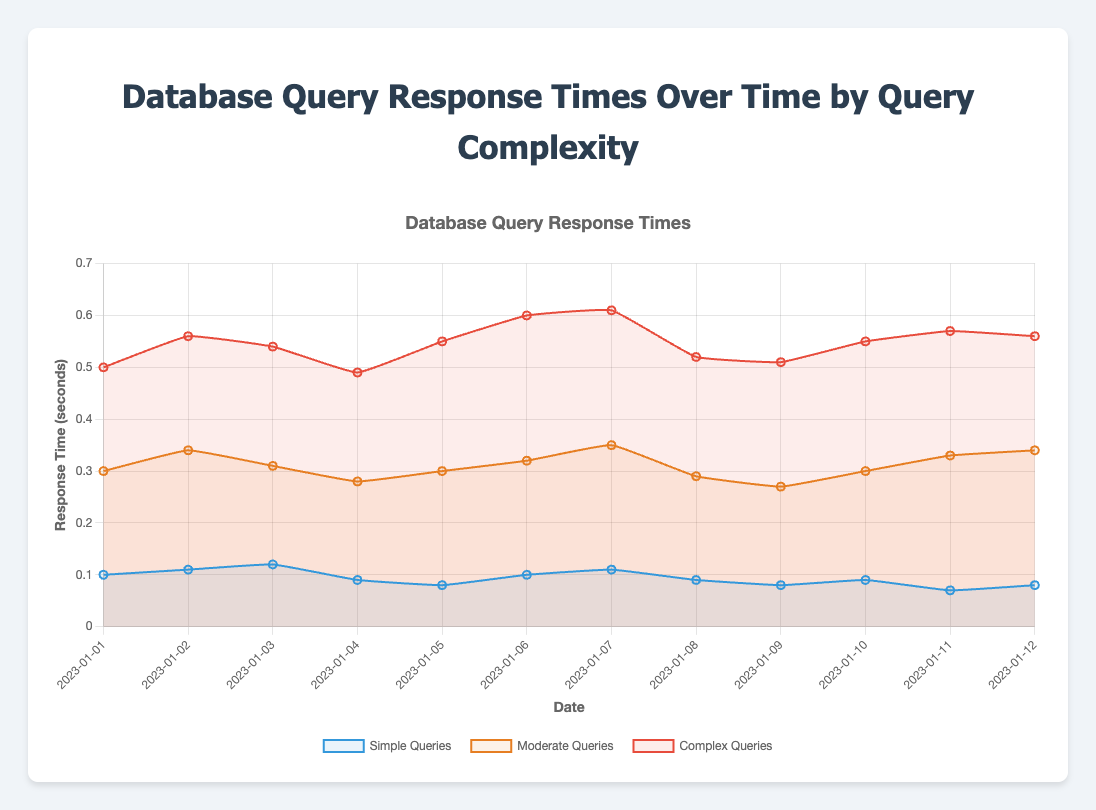What is the date with the lowest response time for simple queries? To find the date with the lowest response time for simple queries, we look at the line representing simple queries and identify the lowest point. The lowest value for simple queries is 0.07 seconds on 2023-01-11.
Answer: 2023-01-11 Which type of query consistently has the highest response time? To determine which type of query consistently has the highest response time, we observe the three lines representing simple, moderate, and complex queries. The red line representing complex queries stays above the others for all dates, indicating the highest response times consistently.
Answer: Complex Queries What is the average response time for moderate queries over the given period? To calculate the average response time for moderate queries, we sum the response times for each date and then divide by the total number of dates. The sum of response times is 3.83 seconds, and there are 12 dates. So, 3.83 / 12 = 0.3192 seconds.
Answer: 0.3192 Compare the response time for simple queries between 2023-01-02 and 2023-01-06. Which is higher? To compare the response times, we look at the simple queries on 2023-01-02 (0.11 seconds) and 2023-01-06 (0.1 seconds). 0.11 is higher than 0.1.
Answer: 2023-01-02 By how much did the response time for complex queries change from 2023-01-01 to 2023-01-07? To find the change in response time, we subtract the response time on 2023-01-01 (0.5 seconds) from the response time on 2023-01-07 (0.61 seconds). The difference is 0.61 - 0.5 = 0.11 seconds.
Answer: 0.11 What color represents the moderate queries in the chart? To identify the color representing the moderate queries, we look at the legend. The moderate queries are represented by the orange line.
Answer: Orange Is there a date where the response times of simple and complex queries are equal? To determine if there is a date where the response times of simple and complex queries are equal, we compare the response times for the entire period. There is no date where the simple and complex queries' response times are the same.
Answer: No On which date did complex queries reach their highest response time? To find the date with the highest response time for complex queries, we look at the peak value on the red line. The highest value, 0.61 seconds, is observed on 2023-01-07.
Answer: 2023-01-07 What is the range of response times for simple queries over the given period? To find the range of response times for simple queries, we identify the highest and lowest values and subtract the lowest from the highest. The highest value is 0.12 seconds, and the lowest is 0.07 seconds. So, 0.12 - 0.07 = 0.05 seconds.
Answer: 0.05 Which type of query shows the most fluctuation in response times over the given period? To determine which type of query shows the most fluctuation, we compare the trends of all lines. The complex queries, represented by the red line, show the most significant changes in response times, indicating the most fluctuation.
Answer: Complex Queries 